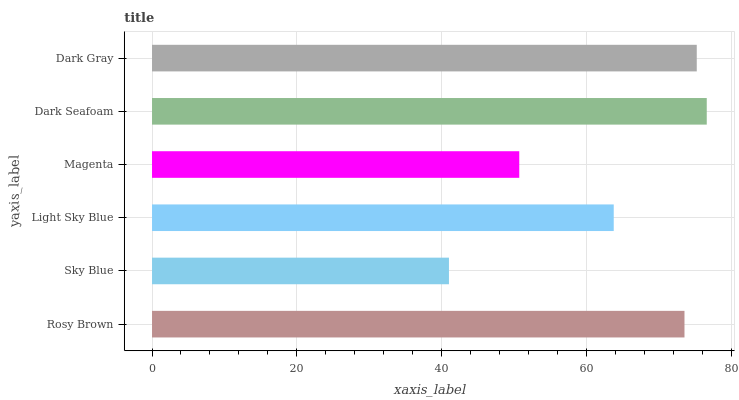Is Sky Blue the minimum?
Answer yes or no. Yes. Is Dark Seafoam the maximum?
Answer yes or no. Yes. Is Light Sky Blue the minimum?
Answer yes or no. No. Is Light Sky Blue the maximum?
Answer yes or no. No. Is Light Sky Blue greater than Sky Blue?
Answer yes or no. Yes. Is Sky Blue less than Light Sky Blue?
Answer yes or no. Yes. Is Sky Blue greater than Light Sky Blue?
Answer yes or no. No. Is Light Sky Blue less than Sky Blue?
Answer yes or no. No. Is Rosy Brown the high median?
Answer yes or no. Yes. Is Light Sky Blue the low median?
Answer yes or no. Yes. Is Magenta the high median?
Answer yes or no. No. Is Rosy Brown the low median?
Answer yes or no. No. 